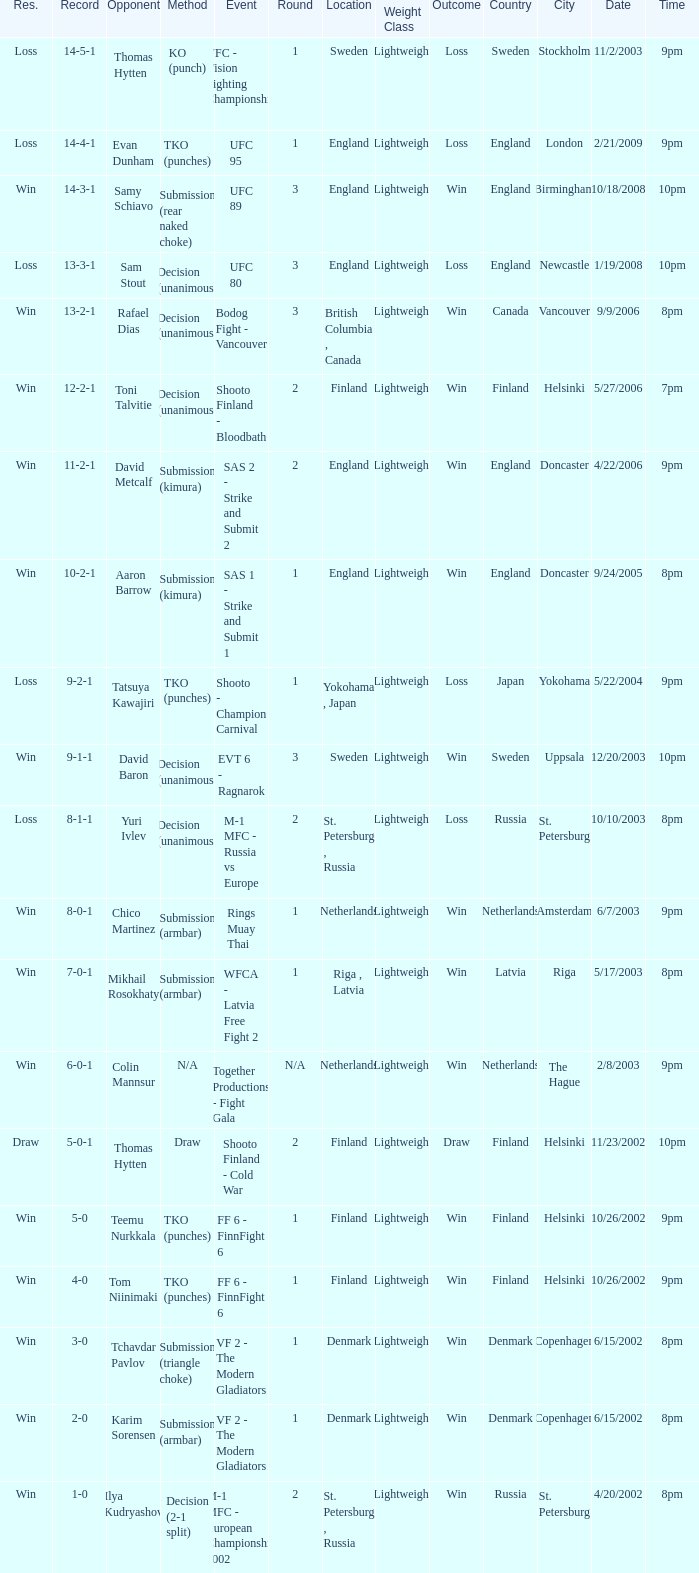Who was the opponent with a record of 14-4-1 and has a round of 1? Evan Dunham. 